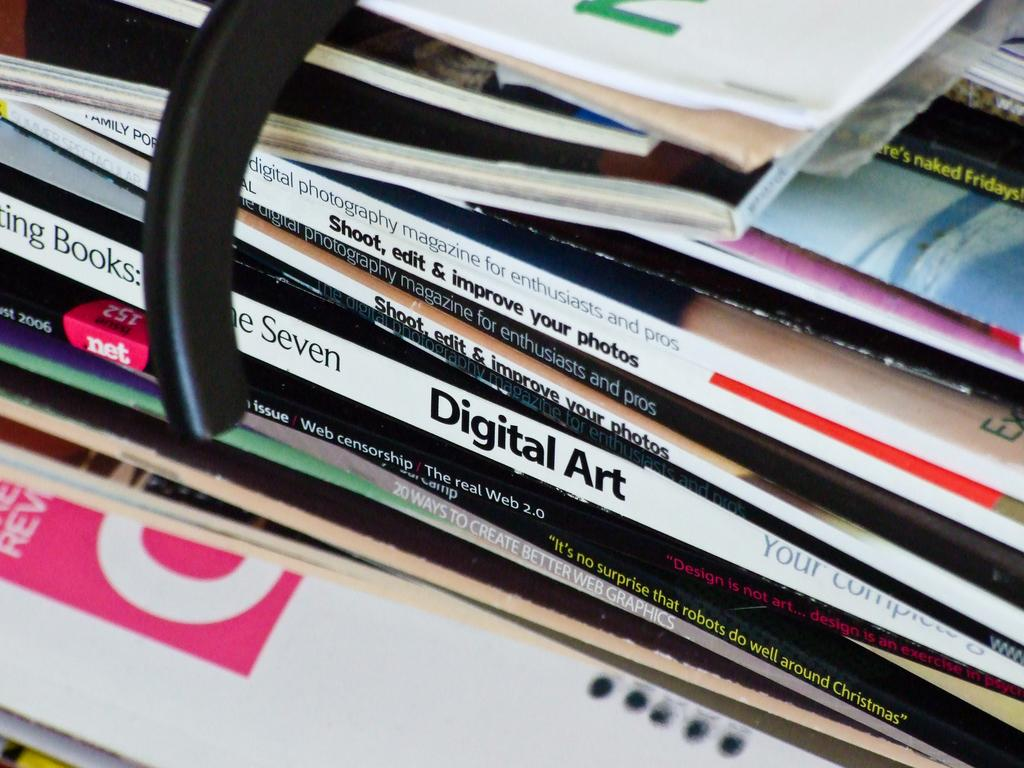<image>
Give a short and clear explanation of the subsequent image. A stack of magazine has an issue of "Digital Art" in the middle of the pile. 